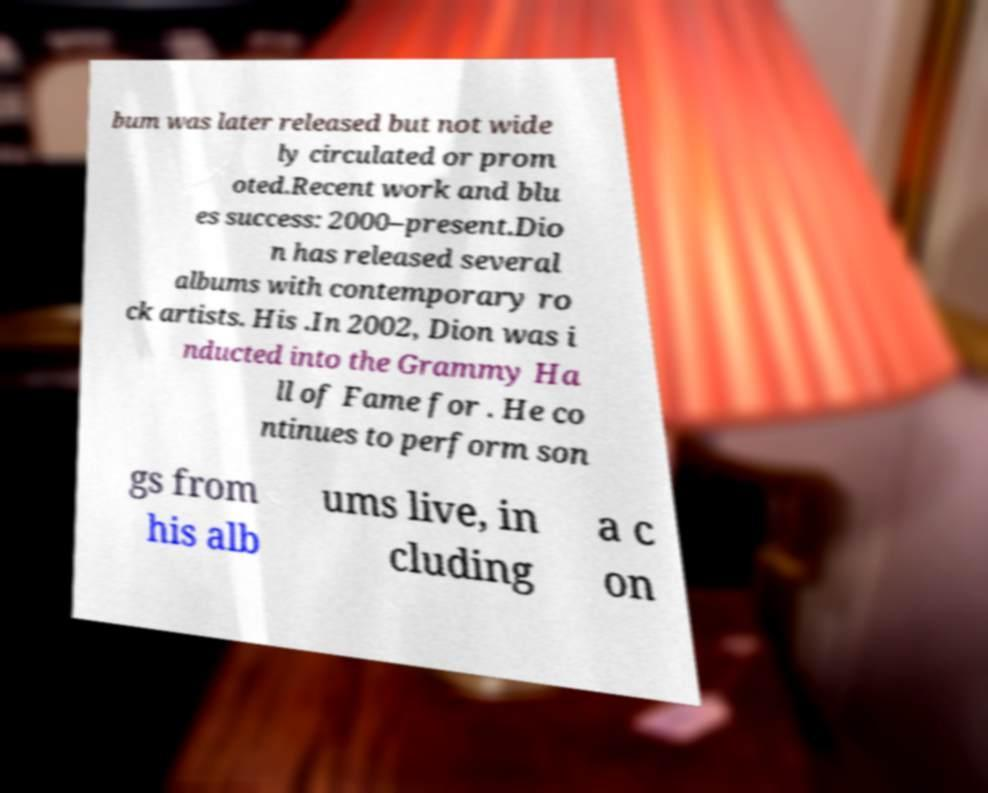For documentation purposes, I need the text within this image transcribed. Could you provide that? bum was later released but not wide ly circulated or prom oted.Recent work and blu es success: 2000–present.Dio n has released several albums with contemporary ro ck artists. His .In 2002, Dion was i nducted into the Grammy Ha ll of Fame for . He co ntinues to perform son gs from his alb ums live, in cluding a c on 